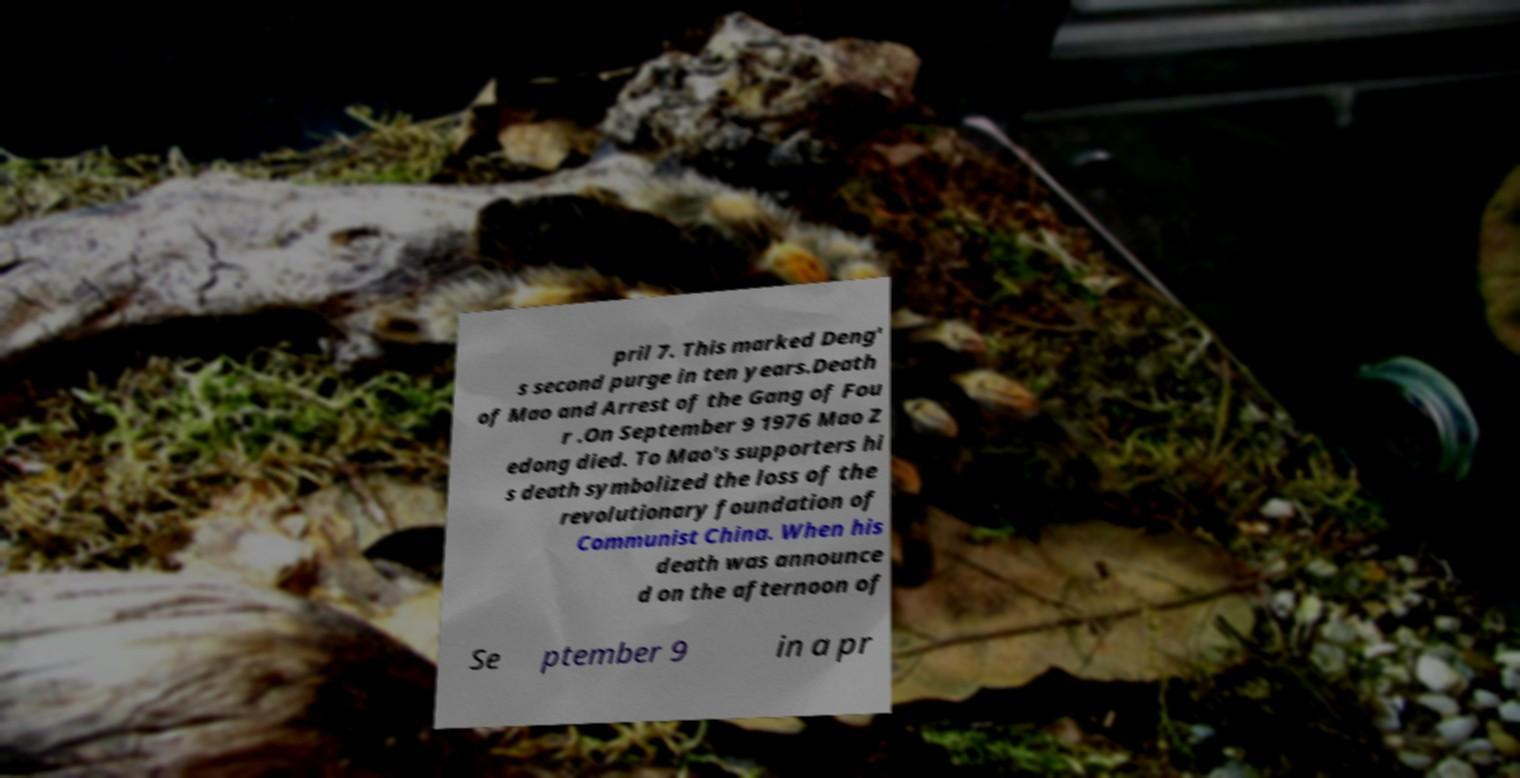What messages or text are displayed in this image? I need them in a readable, typed format. pril 7. This marked Deng' s second purge in ten years.Death of Mao and Arrest of the Gang of Fou r .On September 9 1976 Mao Z edong died. To Mao's supporters hi s death symbolized the loss of the revolutionary foundation of Communist China. When his death was announce d on the afternoon of Se ptember 9 in a pr 